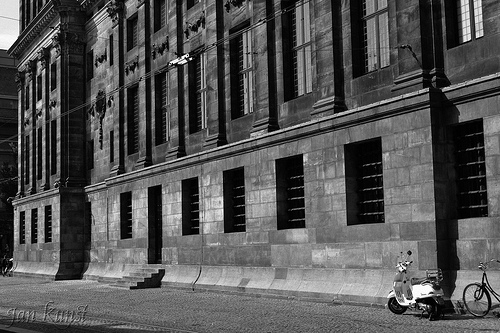What is in front of the doorway? There are stairs leading up to the doorway. 